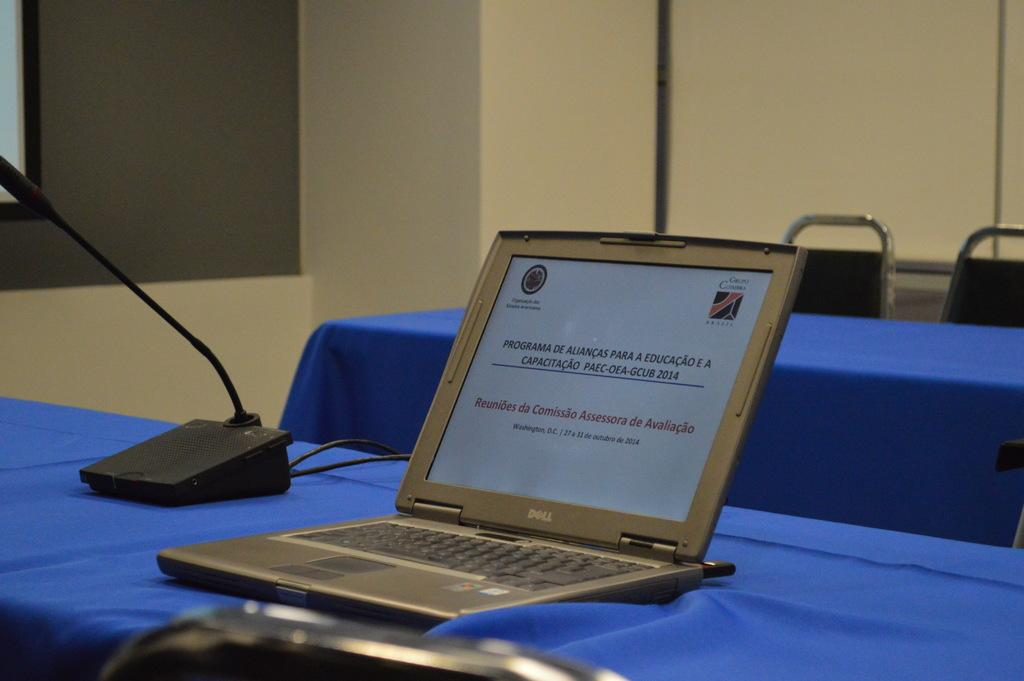<image>
Provide a brief description of the given image. an open Dell lap top computer on a table with a blue table cloth 